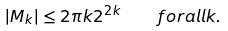Convert formula to latex. <formula><loc_0><loc_0><loc_500><loc_500>| M _ { k } | \leq 2 \pi k 2 ^ { 2 k } \quad f o r a l l k .</formula> 